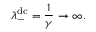<formula> <loc_0><loc_0><loc_500><loc_500>\lambda _ { - } ^ { d c } = \frac { 1 } { \gamma } \rightarrow \infty .</formula> 